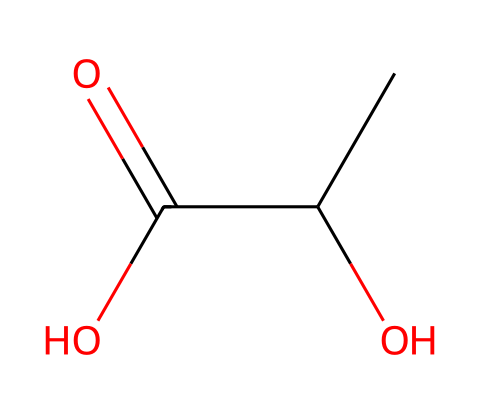What is the name of the compound represented by this SMILES? The SMILES CC(O)C(=O)O corresponds to lactic acid, which is a common organic acid.
Answer: lactic acid How many carbons are in lactic acid? There are three carbon atoms in the structure of lactic acid, as indicated by the 'CC' at the beginning and the carbon in the carboxyl group.
Answer: three Is lactic acid a weak or strong acid? Lactic acid is classified as a weak acid because it does not completely dissociate in water.
Answer: weak What type of isomerism does lactic acid exhibit? Lactic acid exhibits cis-trans (geometric) isomerism due to the presence of the carbon-carbon double bond and two different substituents around that bond.
Answer: cis-trans isomerism In which conformation does the hydroxyl group and the carboxylic acid group occur in lactic acid? In the cis conformation, the hydroxyl group and the carboxylic acid group are on the same side of the double bond, making it less stable than the trans form.
Answer: cis What effect does exercise have on lactic acid production in the body? Exercise increases lactic acid production during anaerobic respiration, leading to a buildup of lactic acid in muscles.
Answer: increases 